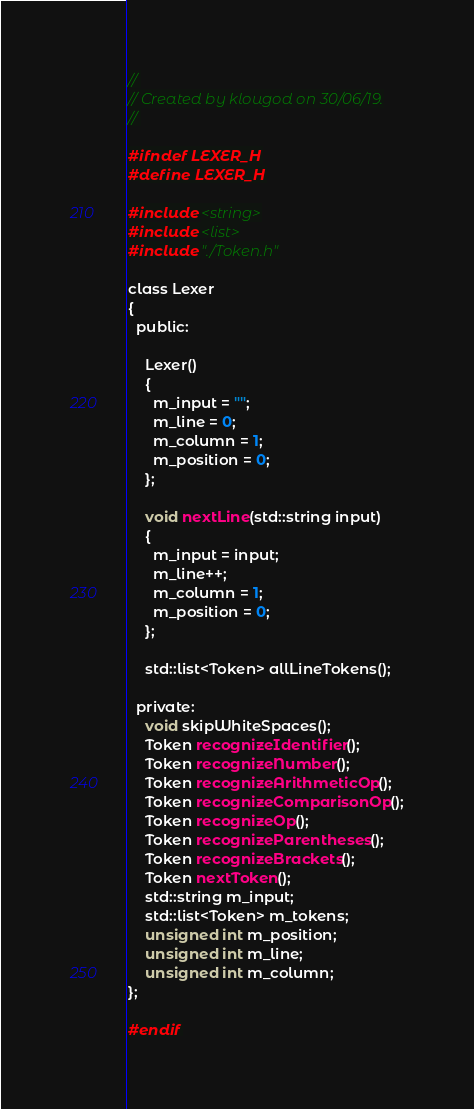Convert code to text. <code><loc_0><loc_0><loc_500><loc_500><_C_>//
// Created by klougod on 30/06/19.
//

#ifndef LEXER_H
#define LEXER_H

#include <string>
#include <list>
#include "./Token.h"

class Lexer
{
  public:
  
    Lexer()
    {
      m_input = "";
      m_line = 0;
      m_column = 1;
      m_position = 0;
    };

    void nextLine(std::string input)
    {
      m_input = input;
      m_line++;
      m_column = 1;
      m_position = 0;
    };

    std::list<Token> allLineTokens();

  private:
    void skipWhiteSpaces();
    Token recognizeIdentifier();
    Token recognizeNumber();
    Token recognizeArithmeticOp();
    Token recognizeComparisonOp();
    Token recognizeOp();
    Token recognizeParentheses();
    Token recognizeBrackets();
    Token nextToken();
    std::string m_input;
    std::list<Token> m_tokens;
    unsigned int m_position;
    unsigned int m_line;
    unsigned int m_column;
};

#endif</code> 